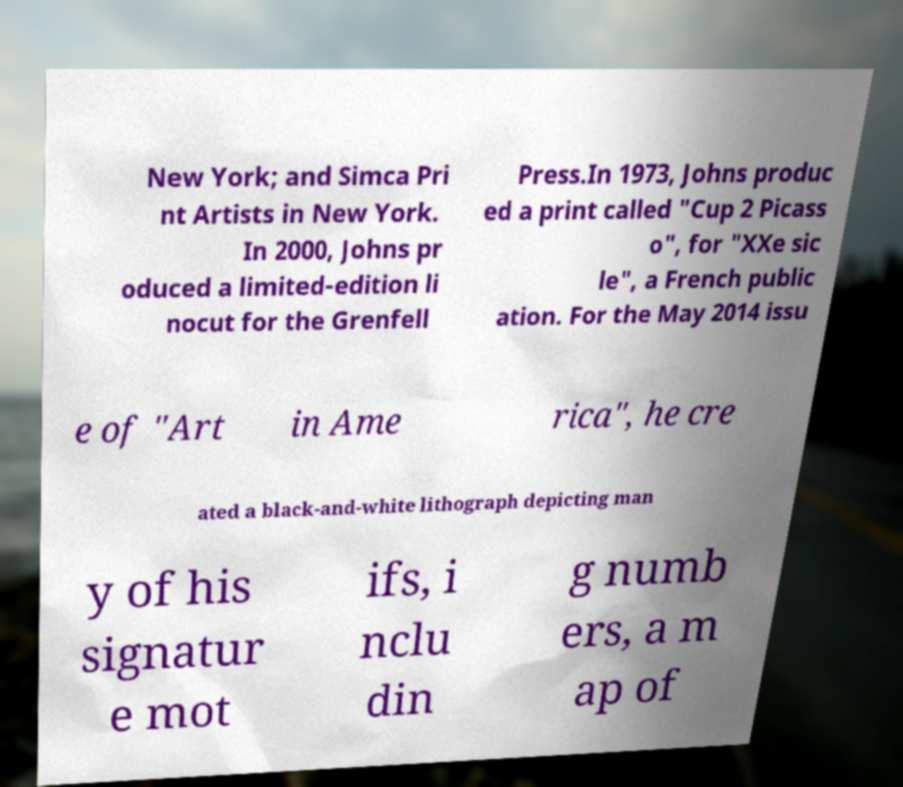Can you accurately transcribe the text from the provided image for me? New York; and Simca Pri nt Artists in New York. In 2000, Johns pr oduced a limited-edition li nocut for the Grenfell Press.In 1973, Johns produc ed a print called "Cup 2 Picass o", for "XXe sic le", a French public ation. For the May 2014 issu e of "Art in Ame rica", he cre ated a black-and-white lithograph depicting man y of his signatur e mot ifs, i nclu din g numb ers, a m ap of 